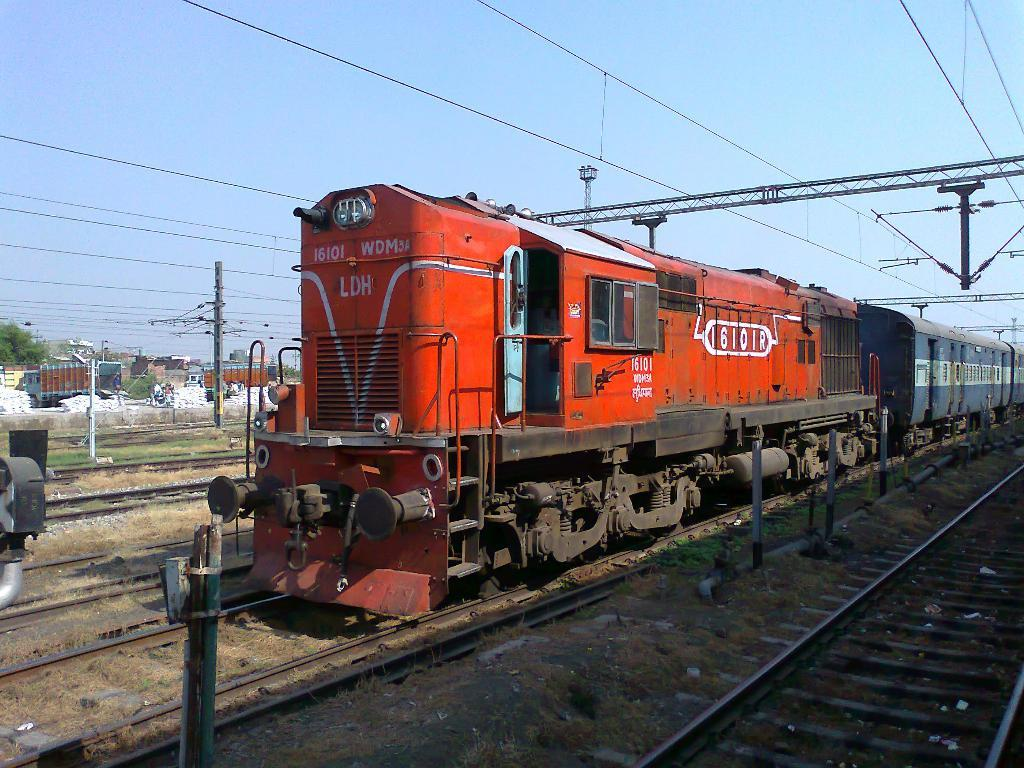<image>
Render a clear and concise summary of the photo. A red train with number 16101R on the side is riding down the tracks. 